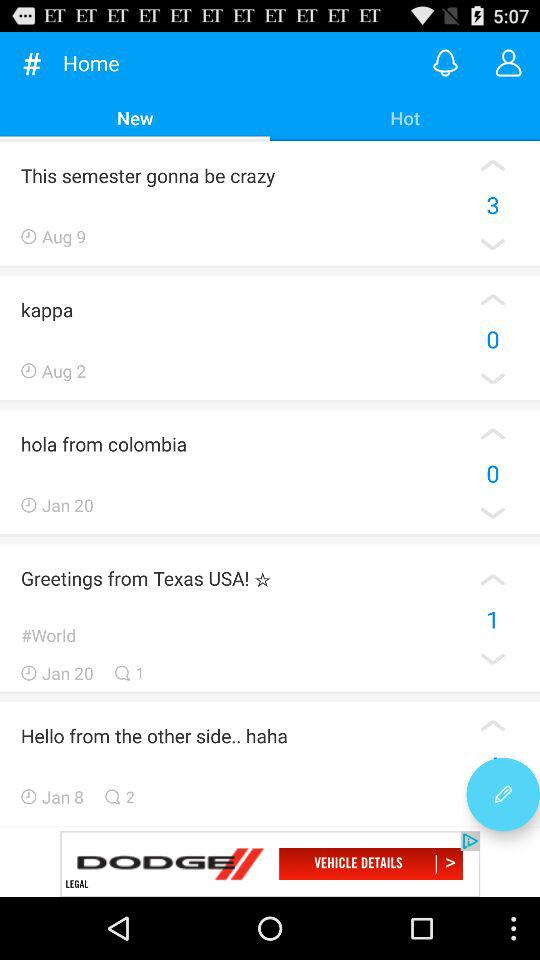Which tab is selected? The selected tab is "New". 